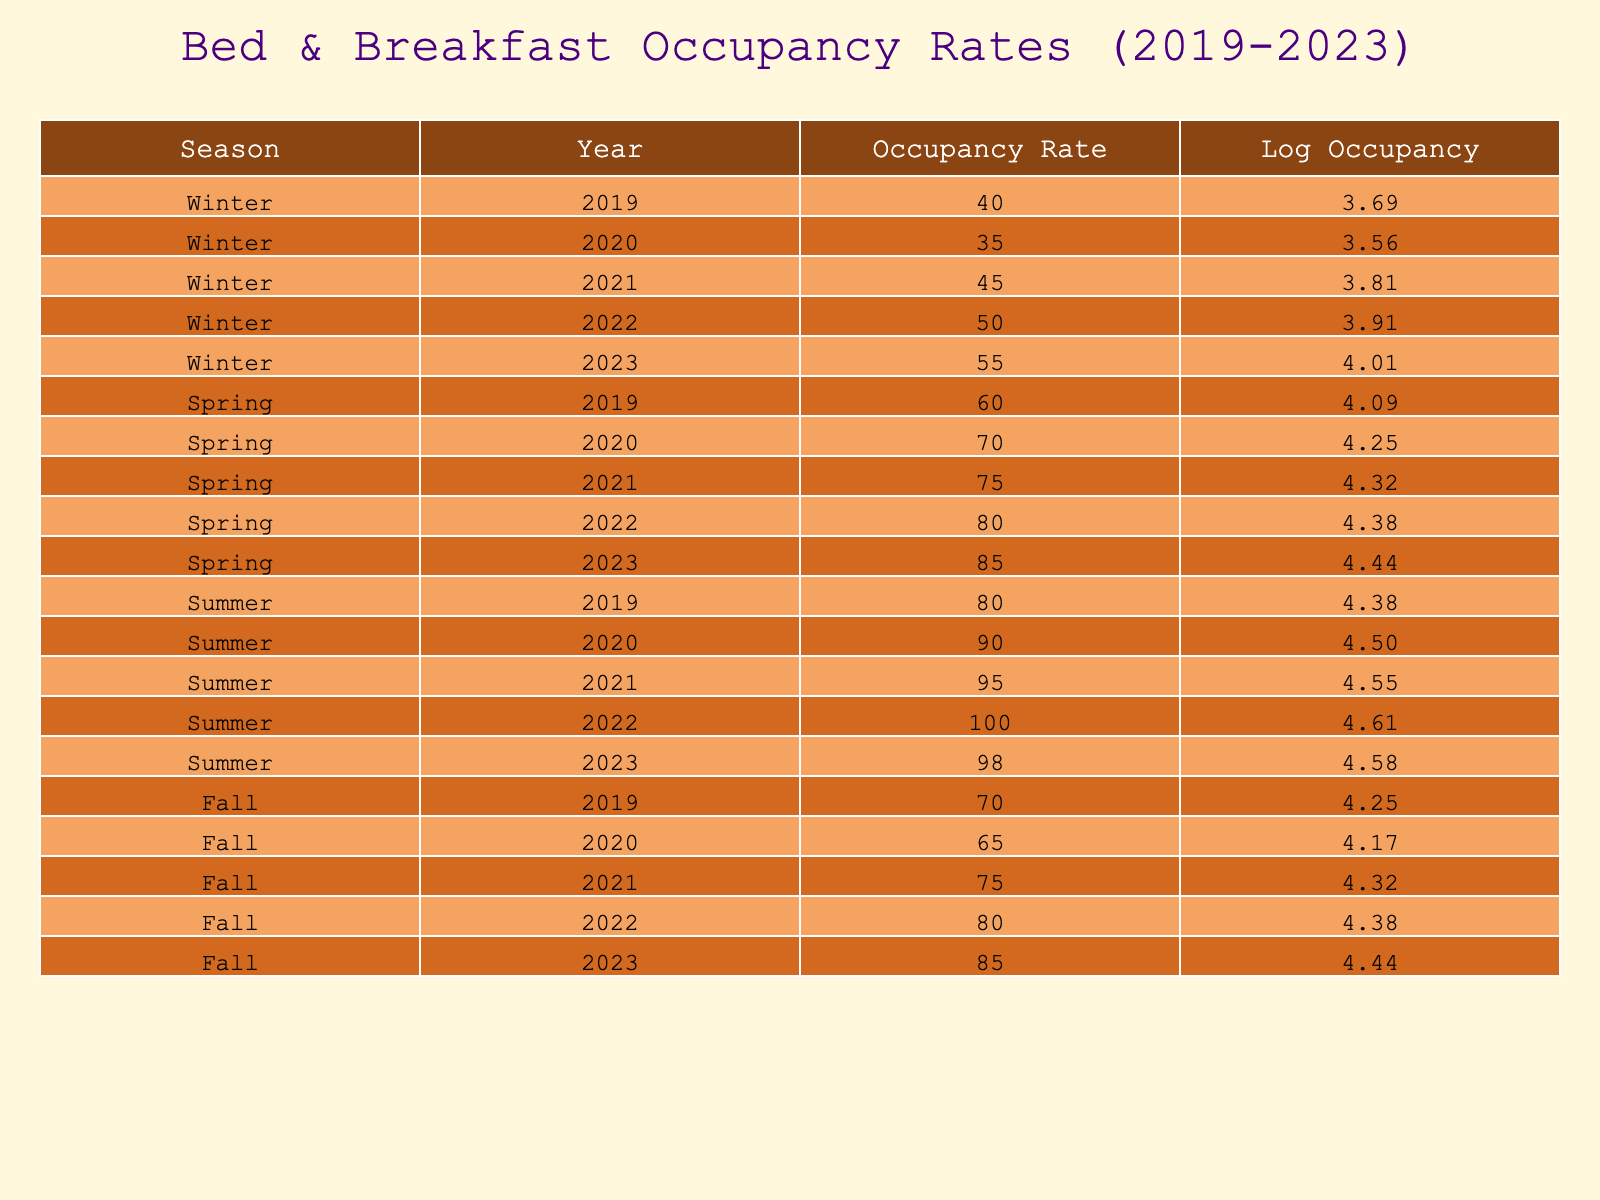What was the occupancy rate for Winter in 2022? According to the table, the occupancy rate for Winter in 2022 is listed directly under the Winter section and corresponds to the year 2022. The value given is 50.
Answer: 50 What is the logarithmic value of the occupancy rate for Spring in 2023? The occupancy rate for Spring in 2023 is 85. To find the logarithmic value, you look at the Log Occupancy column for that specific row. The logarithm of 85 is approximately 4.4427.
Answer: 4.44 What was the highest recorded occupancy rate across all seasons in 2022? In 2022, the occupancy rates for each season were Winter (50), Spring (80), Summer (100), and Fall (80). The highest of these values is Summer at 100.
Answer: 100 What is the average occupancy rate for Fall over the five years? The occupancy rates for Fall from 2019-2023 are 70, 65, 75, 80, and 85. To find the average, sum these values: (70 + 65 + 75 + 80 + 85) = 375. Then divide by the number of years: 375/5 = 75.
Answer: 75 Is the occupancy rate for Summer in 2021 higher than the occupancy rate for Winter in 2023? The table shows the Summer occupancy rate for 2021 as 95 and the Winter rate for 2023 as 55. Since 95 is greater than 55, the statement is true.
Answer: Yes What was the change in occupancy rate for Spring from 2019 to 2023? The occupancy rate for Spring in 2019 is 60, and in 2023 it is 85. To find the change, subtract the earlier rate from the later rate: 85 - 60 = 25. This indicates an increase of 25 percentage points.
Answer: 25 Was the occupancy rate in Winter for 2020 lower than the average occupancy rates of Spring in the same year? The Winter occupancy rate for 2020 is 35, while the Spring occupancy rate for 2020 is 70. Since 35 is less than 70, the statement is true.
Answer: Yes How much did the occupancy rate for Fall improve from 2020 to 2023? The occupancy rates for Fall in 2020 is 65 and in 2023 is 85. To find the improvement, take the difference: 85 - 65 = 20. This indicates an improvement of 20 percentage points over three years.
Answer: 20 What season had the largest increase in occupancy rates from 2019 to 2023? To determine this, we look at the occupancy rates: Winter increased from 40 to 55 (15 points), Spring from 60 to 85 (25 points), Summer from 80 to 98 (18 points), and Fall from 70 to 85 (15 points). The largest increase is in Spring with 25 points.
Answer: Spring 